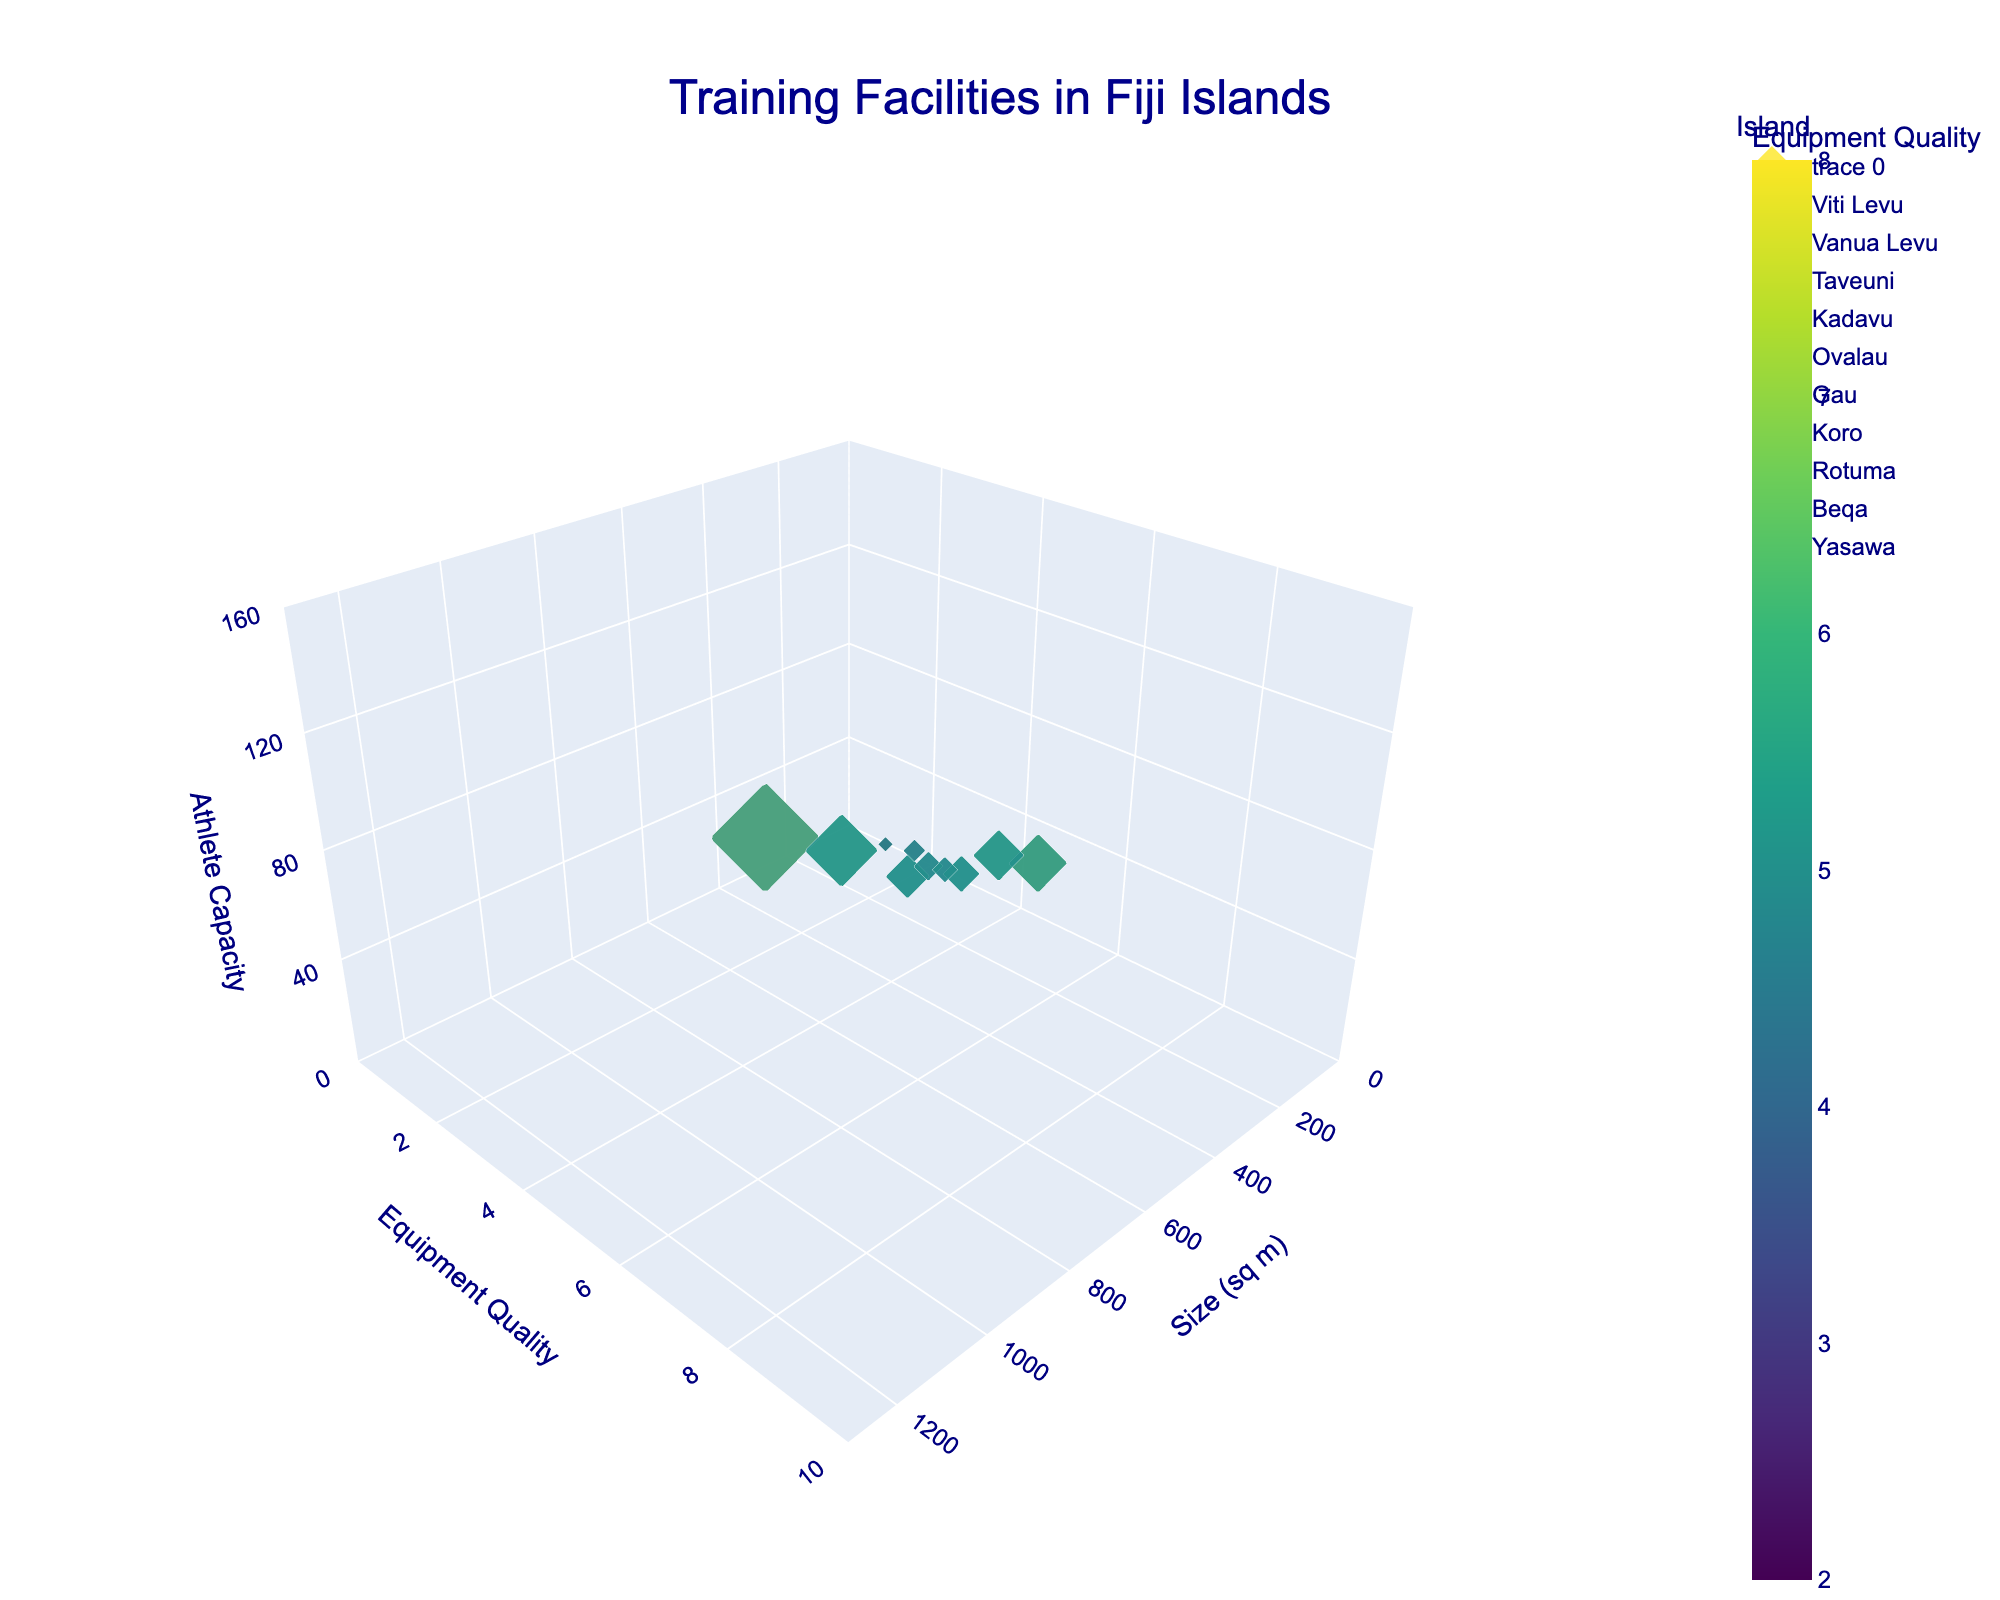What is the title of the figure? The title is prominently displayed at the top center of the figure and reads "Training Facilities in Fiji Islands".
Answer: Training Facilities in Fiji Islands How many training facilities are represented in the figure? By counting the number of distinct data points (bubbles) in the figure, you can determine that there are 10 training facilities represented.
Answer: 10 Which training facility has the highest athlete capacity? By looking at the z-axis (Athlete Capacity) and finding the tallest bubble, you can identify the "Suva Olympic Center" as the facility with the highest athlete capacity.
Answer: Suva Olympic Center What is the Equipment Quality of the "Levuka Legacy Gym"? By finding the bubble labeled "Levuka Legacy Gym" and reading the y-axis value, the Equipment Quality can be determined as 7.
Answer: 7 Which island has the smallest training facility in terms of size? By examining the x-axis (Size in sq m) and locating the smallest bubble, you can identify "Beqa" as having the smallest facility at 150 sq m.
Answer: Beqa Which facility has an Equipment Quality of 4 and how many athletes can it accommodate? By identifying bubbles at y=4 on the y-axis and reading the z-axis values, the facilities are "Vunisea Training Ground" and "Ahau Community Center", accommodating 40 and 35 athletes, respectively.
Answer: Vunisea Training Ground and Ahau Community Center; 40 and 35 How does the "Labasa Sports Complex" compare to the "Taveuni Fitness Hub" in terms of athlete capacity and equipment quality? "Labasa Sports Complex" has an athlete capacity of 100 and an Equipment Quality of 6, while "Taveuni Fitness Hub" has an athlete capacity of 60 and an Equipment Quality of 5. Labasa Sports Complex has higher values in both metrics.
Answer: Labasa Sports Complex is higher in both metrics What’s the average size (in sq m) of training facilities on the islands with an Equipment Quality of 5? Facilities with an Equipment Quality of 5 are "Taveuni Fitness Hub" (500 sq m) and "Nasau Athletics Field" (350 sq m). The average size is (500 + 350) / 2 = 425 sq m.
Answer: 425 sq m Which facility, with athlete capacity less than 50, has the best Equipment Quality? Facilities with athlete capacity less than 50 are "Vunisea Training Ground" (Quality 4), "Qarani Village Fitness Area" (Quality 3), "Ahau Community Center" (Quality 4), and "Lalati Village Training Spot" (Quality 2). The "Vunisea Training Ground" and "Ahau Community Center" both have the best Equipment Quality of 4.
Answer: Vunisea Training Ground and Ahau Community Center Which training facility has the largest bubble and what does that signify? The largest bubble signifies the highest athlete capacity and belongs to the "Suva Olympic Center", indicating it can accommodate the most athletes at 150.
Answer: Suva Olympic Center, 150 athletes 